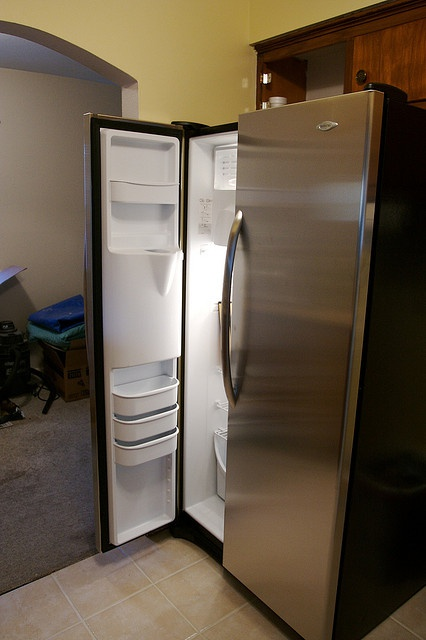Describe the objects in this image and their specific colors. I can see a refrigerator in tan, black, gray, darkgray, and maroon tones in this image. 